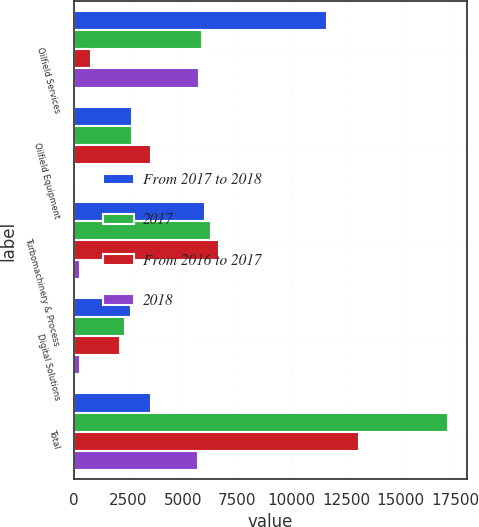Convert chart to OTSL. <chart><loc_0><loc_0><loc_500><loc_500><stacked_bar_chart><ecel><fcel>Oilfield Services<fcel>Oilfield Equipment<fcel>Turbomachinery & Process<fcel>Digital Solutions<fcel>Total<nl><fcel>From 2017 to 2018<fcel>11617<fcel>2641<fcel>6015<fcel>2604<fcel>3540<nl><fcel>2017<fcel>5881<fcel>2661<fcel>6295<fcel>2342<fcel>17179<nl><fcel>From 2016 to 2017<fcel>788<fcel>3540<fcel>6668<fcel>2086<fcel>13082<nl><fcel>2018<fcel>5736<fcel>20<fcel>280<fcel>262<fcel>5698<nl></chart> 